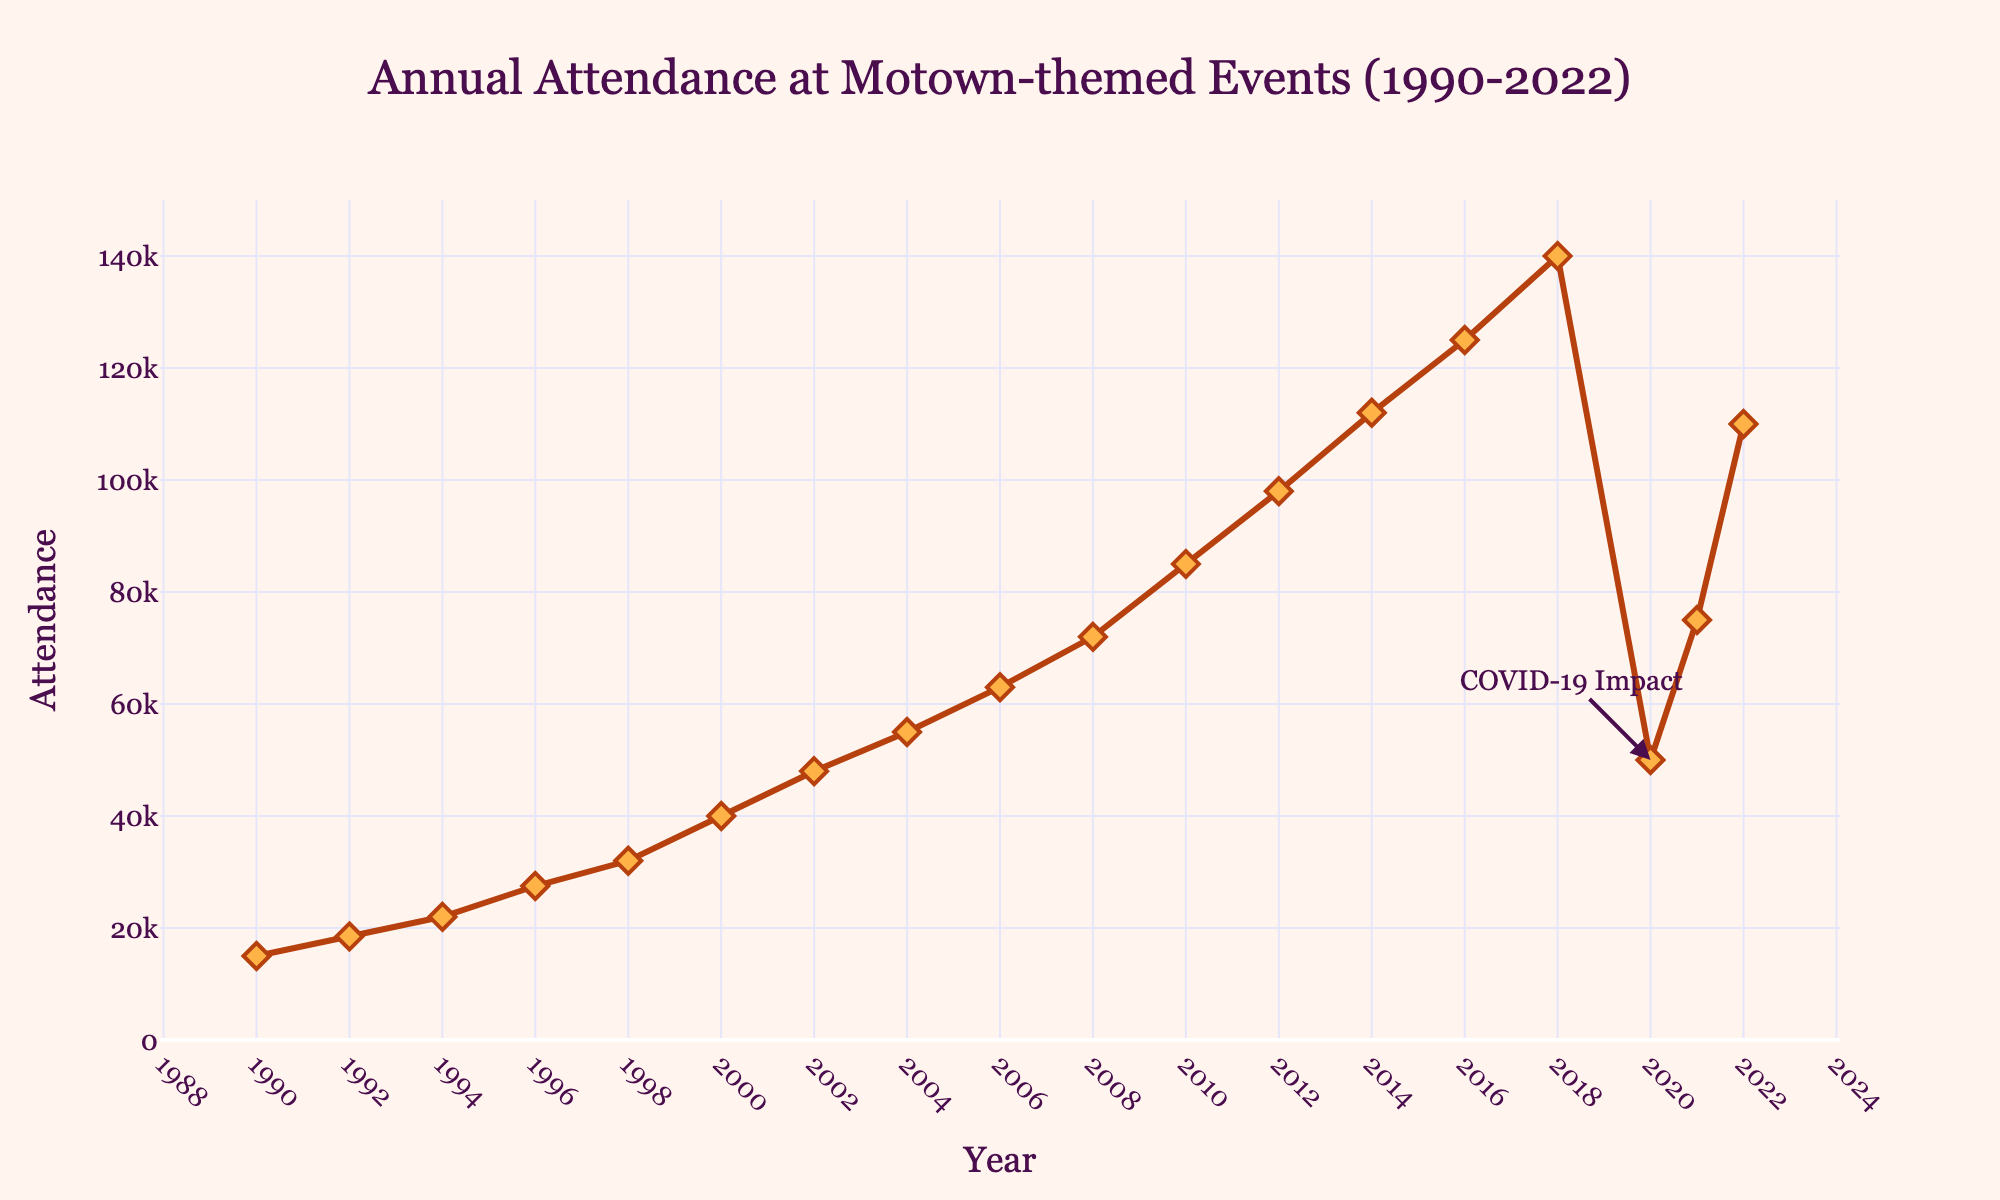What's the trend in attendance from 1990 to 2022? The trend shows a general increase in attendance from 1990 to 2018, a significant drop in 2020, likely due to COVID-19, followed by a recovery in 2021 and 2022.
Answer: Increasing with a dip in 2020 What year saw the highest attendance at Motown-themed events? To find the highest attendance, look at the peak of the line graph. The highest point is in 2018 with 140,000 attendees.
Answer: 2018 How did attendance change between 2018 and 2020? In 2018, attendance was 140,000. By 2020, it decreased significantly to 50,000.
Answer: Decreased by 90,000 What is the difference in attendance between 1996 and 2000? Attendance in 1996 was 27,500 and in 2000 it was 40,000. The difference is 40,000 - 27,500 = 12,500.
Answer: 12,500 How did the COVID-19 pandemic impact the attendance at Motown-themed events in 2020? The annotation on the plot indicates "COVID-19 Impact" at 2020. The attendance dropped from 140,000 in 2018 to 50,000 in 2020.
Answer: Attendance dropped significantly Which year had a better recovery after 2020, 2021 or 2022? Comparing the attendance values, 2021 had 75,000, and 2022 had 110,000.
Answer: 2022 By how much did attendance increase from 1990 to 1994? Attendance in 1990 was 15,000 and in 1994 it was 22,000. So the increase is 22,000 - 15,000 = 7,000.
Answer: 7,000 What visual elements indicate a significant event impacting attendance in 2020? There is an annotation pointing to the year 2020 with the text "COVID-19 Impact," indicating this is a significant event affecting the data.
Answer: Annotation with "COVID-19 Impact" When looking at the color and style of the line and markers, what can you infer about the visual design choices? The line is a reddish-brown color with orange diamond markers, suggesting an emphasis on distinguishing each data point clearly. This choice helps maintain a Motown aesthetic with a classic color scheme.
Answer: Emphasis on distinguishable data points and classic color scheme How consistent was the growth in attendance from 1990 to 2018 before the dip in 2020? From 1990 to 2018, the attendance consistently increased each year without any significant drops, suggesting steady growth in popularity.
Answer: Steadily increasing 